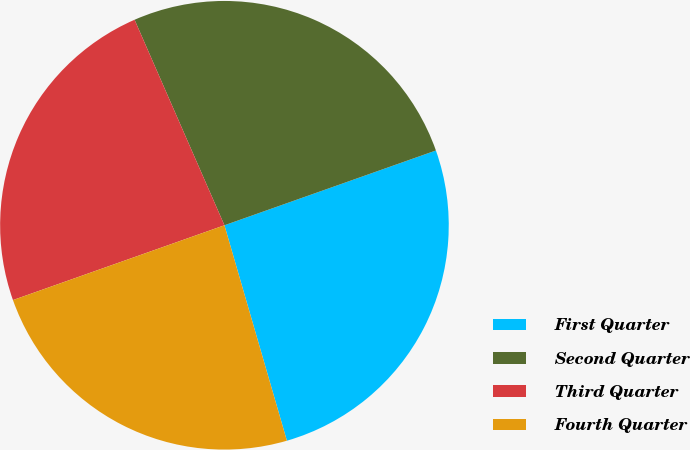Convert chart to OTSL. <chart><loc_0><loc_0><loc_500><loc_500><pie_chart><fcel>First Quarter<fcel>Second Quarter<fcel>Third Quarter<fcel>Fourth Quarter<nl><fcel>25.92%<fcel>26.15%<fcel>23.85%<fcel>24.08%<nl></chart> 